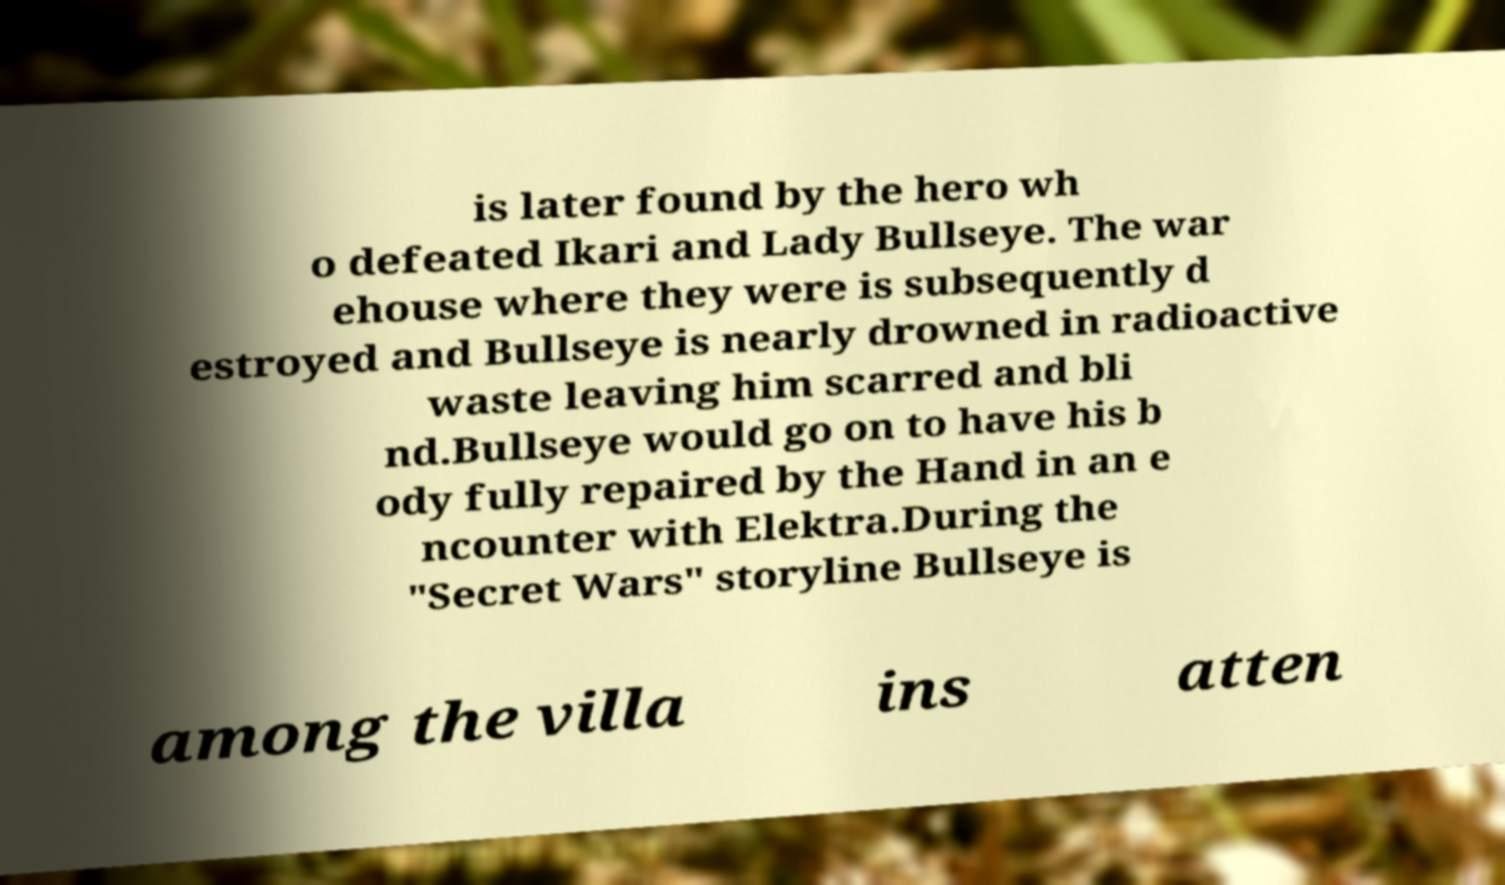Please identify and transcribe the text found in this image. is later found by the hero wh o defeated Ikari and Lady Bullseye. The war ehouse where they were is subsequently d estroyed and Bullseye is nearly drowned in radioactive waste leaving him scarred and bli nd.Bullseye would go on to have his b ody fully repaired by the Hand in an e ncounter with Elektra.During the "Secret Wars" storyline Bullseye is among the villa ins atten 